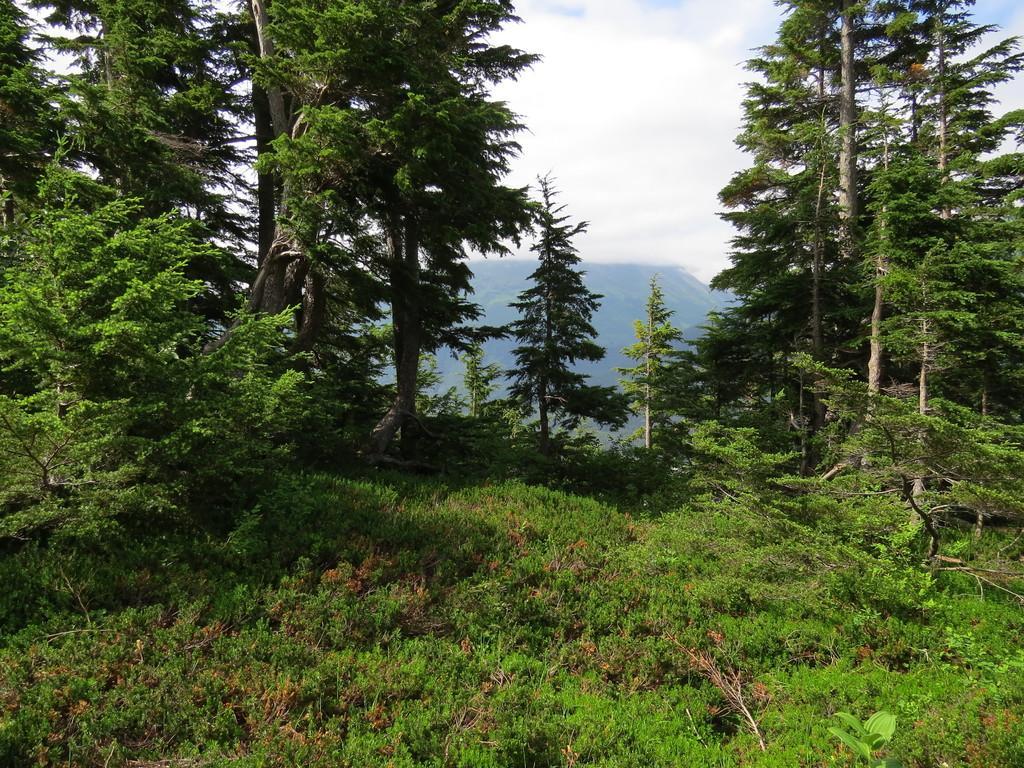Please provide a concise description of this image. In this image there are so many trees in the middle. At the bottom there is ground on which there are small plants and grass. At the top there is the sky. In the background there are mountains. 